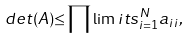Convert formula to latex. <formula><loc_0><loc_0><loc_500><loc_500>d e t ( A ) { \leq } \prod \lim i t s _ { i = 1 } ^ { N } a _ { i i } ,</formula> 